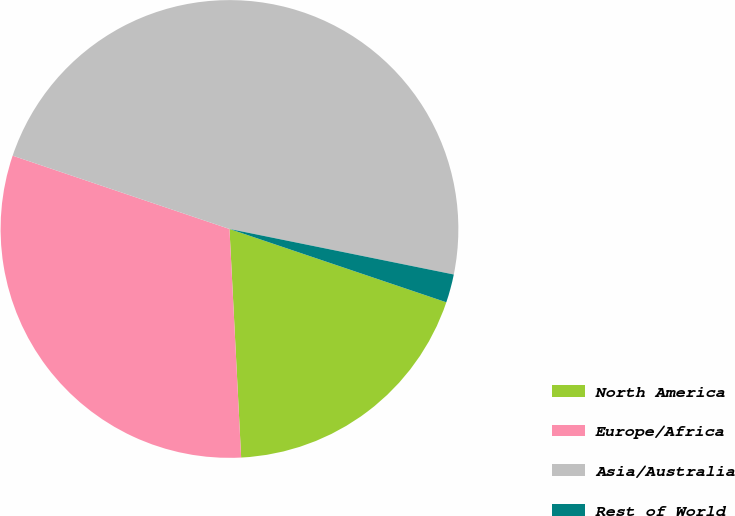Convert chart to OTSL. <chart><loc_0><loc_0><loc_500><loc_500><pie_chart><fcel>North America<fcel>Europe/Africa<fcel>Asia/Australia<fcel>Rest of World<nl><fcel>19.0%<fcel>31.0%<fcel>48.0%<fcel>2.0%<nl></chart> 